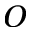<formula> <loc_0><loc_0><loc_500><loc_500>O</formula> 